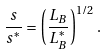Convert formula to latex. <formula><loc_0><loc_0><loc_500><loc_500>\frac { s } { s ^ { \ast } } = \left ( \frac { L _ { B } } { L _ { B } ^ { \ast } } \right ) ^ { 1 / 2 } .</formula> 